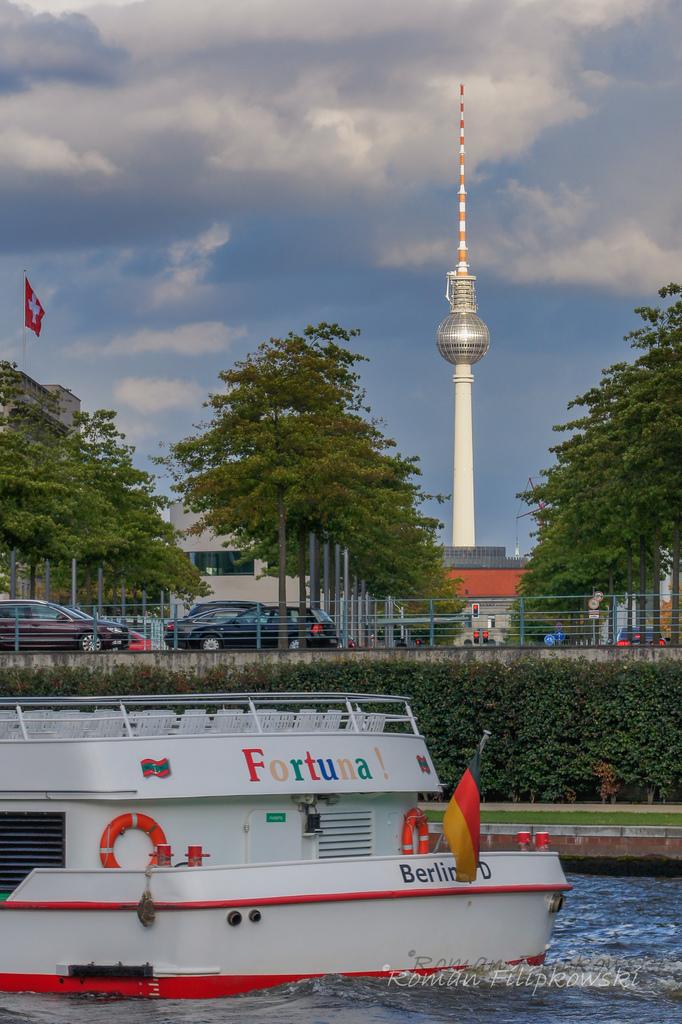What boat is this?
Offer a very short reply. Fortuna. Where is the boat from?
Your answer should be very brief. Berlin. 